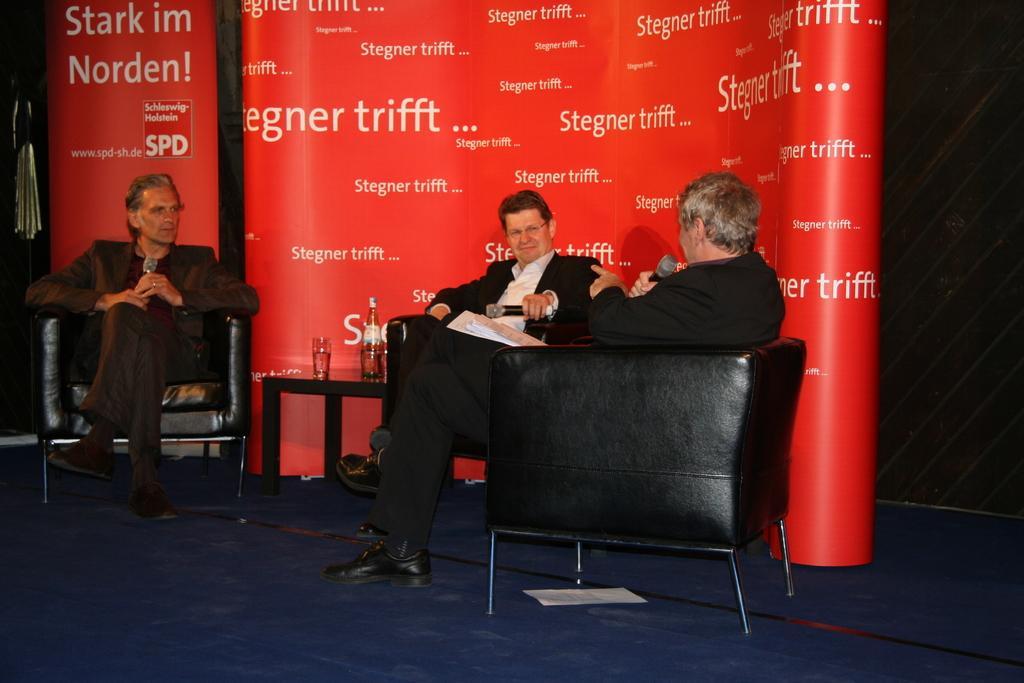In one or two sentences, can you explain what this image depicts? In the image we can see there are tree men who are sitting on chair and they are holding mike in their hand and on which it's written "Stregner trifft". 